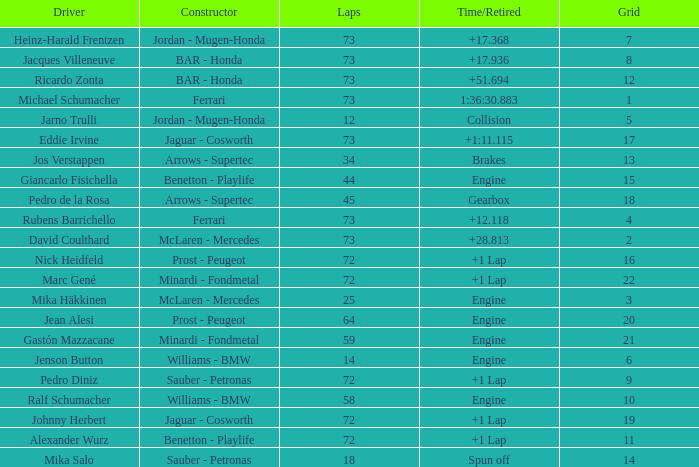How many laps did Giancarlo Fisichella do with a grid larger than 15? 0.0. 